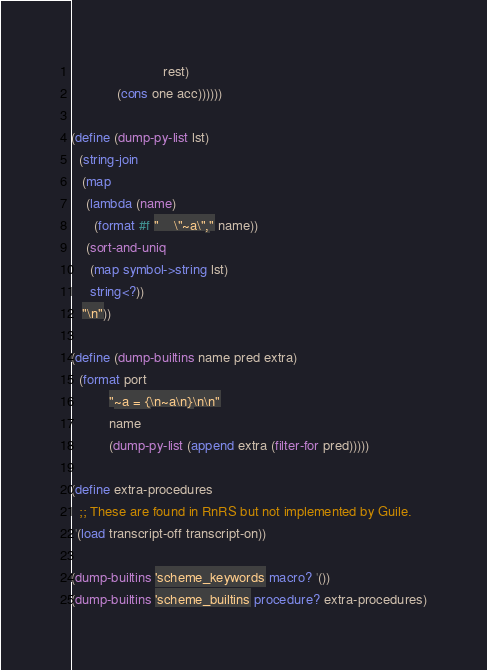Convert code to text. <code><loc_0><loc_0><loc_500><loc_500><_Scheme_>                        rest)
            (cons one acc))))))

(define (dump-py-list lst)
  (string-join
   (map
    (lambda (name)
      (format #f "    \"~a\"," name))
    (sort-and-uniq
     (map symbol->string lst)
     string<?))
   "\n"))

(define (dump-builtins name pred extra)
  (format port
          "~a = {\n~a\n}\n\n"
          name
          (dump-py-list (append extra (filter-for pred)))))

(define extra-procedures
  ;; These are found in RnRS but not implemented by Guile.
 '(load transcript-off transcript-on))

(dump-builtins 'scheme_keywords macro? '())
(dump-builtins 'scheme_builtins procedure? extra-procedures)
</code> 